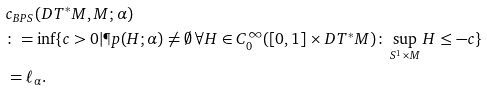Convert formula to latex. <formula><loc_0><loc_0><loc_500><loc_500>& c _ { B P S } ( D T ^ { * } M , M ; \alpha ) \\ & \colon = \inf \{ c > 0 | \P p ( H ; \alpha ) \not = \emptyset \, \forall H \in C ^ { \infty } _ { 0 } ( [ 0 , 1 ] \times D T ^ { * } M ) \colon \sup _ { S ^ { 1 } \times M } H \leq - c \} \\ & = \ell _ { \alpha } .</formula> 